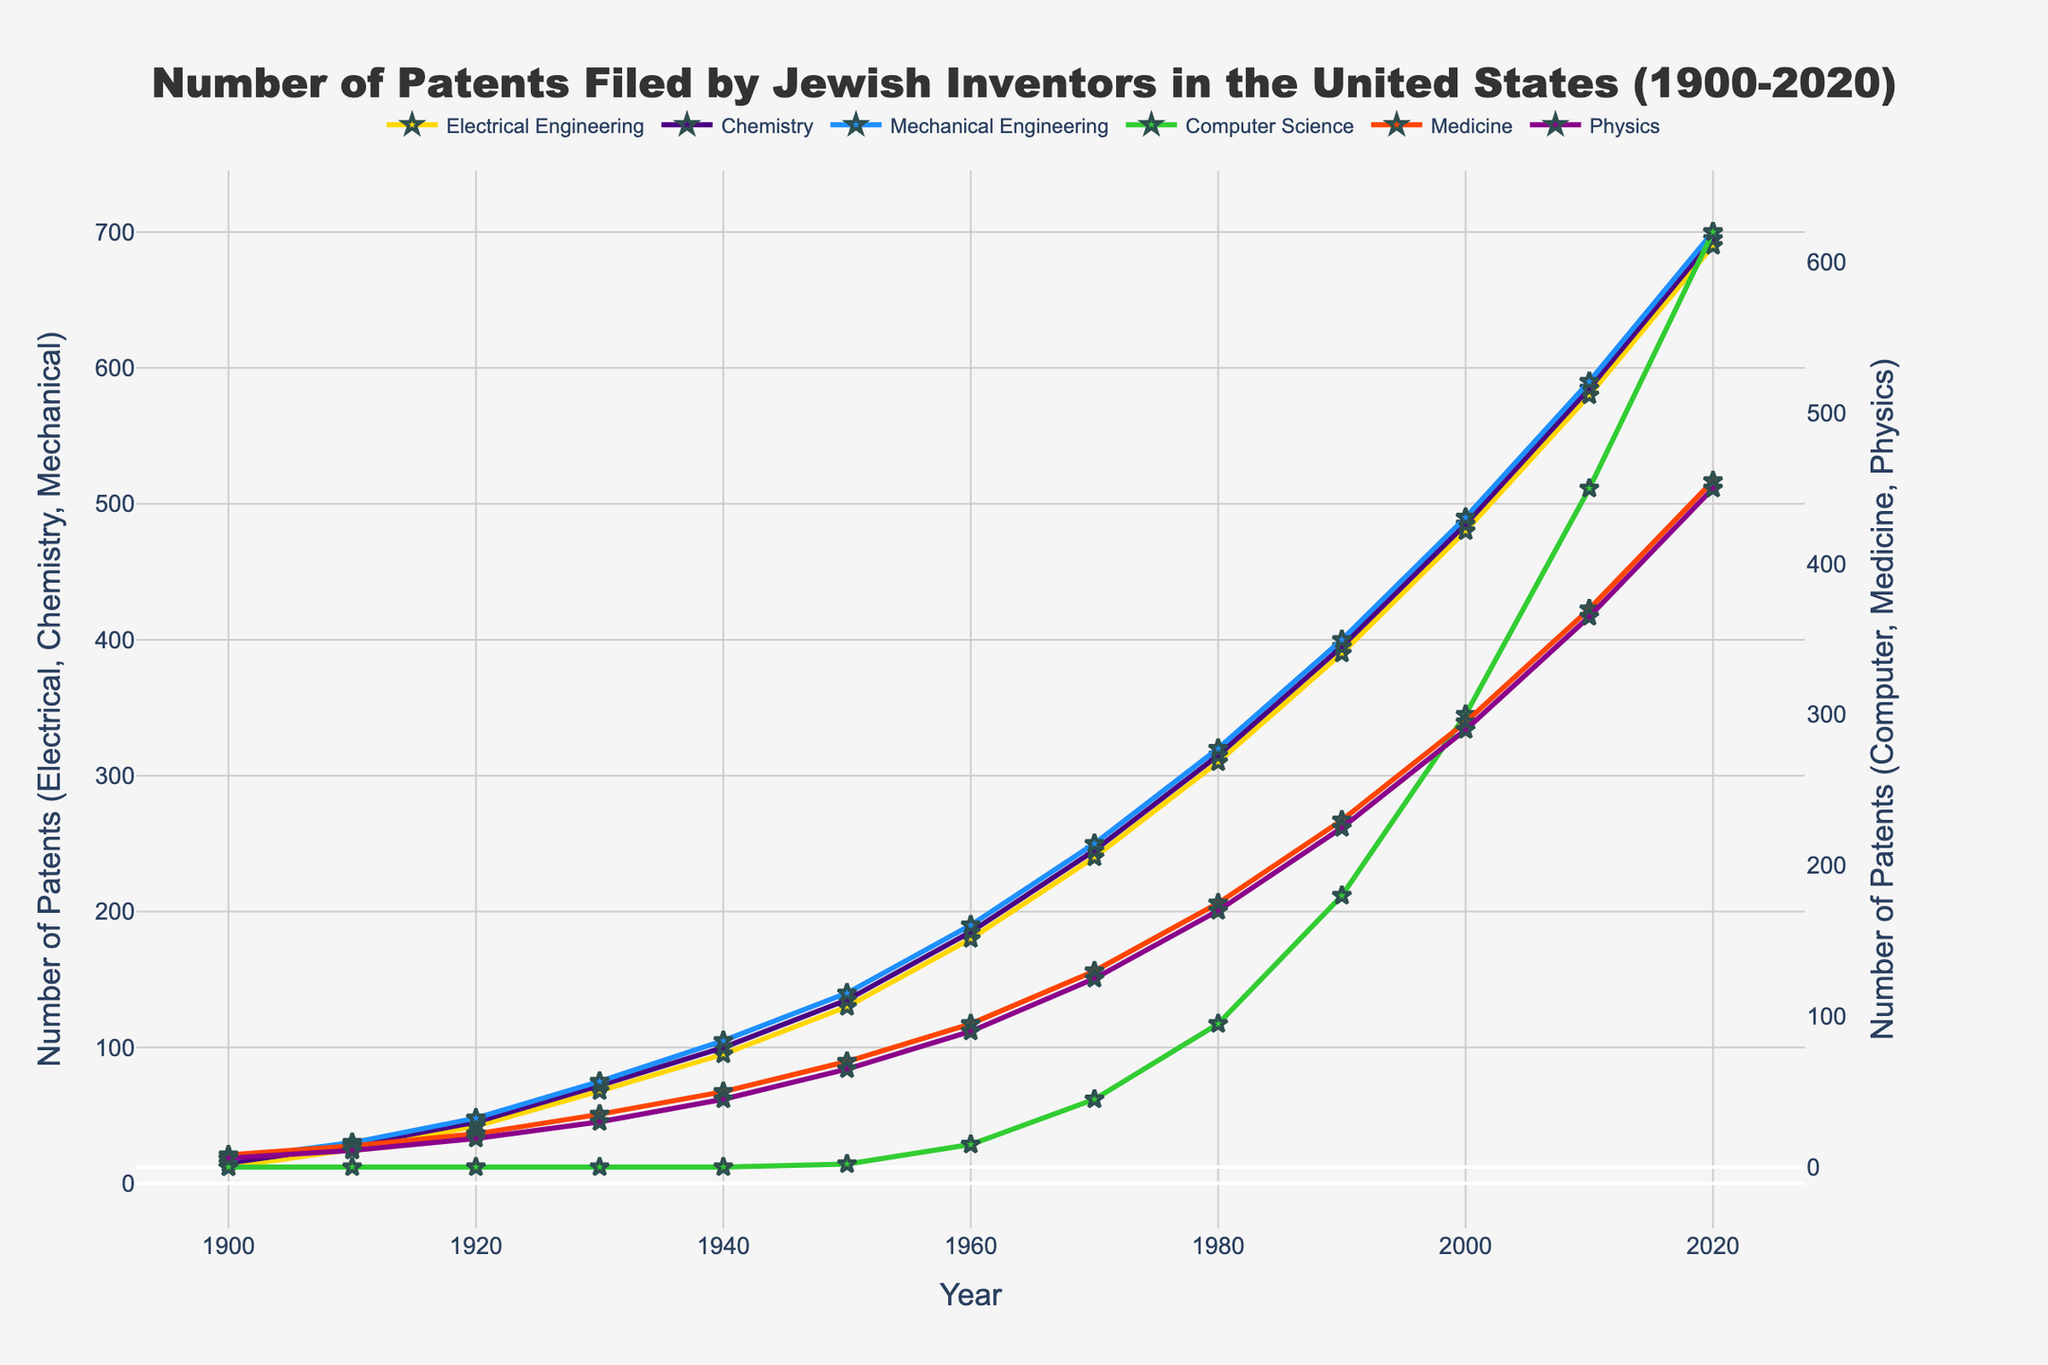what is the trend in the number of patents filed in Electrical Engineering from 1900 to 2020? From 1900 to 2020, the number of patents filed in Electrical Engineering shows an upward trend. In 1900, there were 12 patents, and by 2020, this number increased to 690. The increase is consistent over the decades.
Answer: Upward trend In which decade did Chemistry see the largest increase in patents filed? The number of patents filed in Chemistry increased the most between the 1950s (135 patents) and 1960s (185 patents). The increase is 185 - 135 = 50 patents.
Answer: 1950s to 1960s How does the number of patents filed in Computer Science in 2000 compare to 2010? In 2000, 300 patents were filed, and by 2010, it increased to 450 patents. The difference is 450 - 300 = 150.
Answer: 150 more in 2010 Which field had the highest number of patents filed in 2020? In 2020, Mechanical Engineering had the highest number of patents filed at 700.
Answer: Mechanical Engineering What is the total number of patents filed over all fields in 2020? Sum the patents for all fields in 2020: 690 (Electrical Engineering) + 695 (Chemistry) + 700 (Mechanical Engineering) + 620 (Computer Science) + 455 (Medicine) + 450 (Physics) = 3610 patents.
Answer: 3610 patents What is the average number of patents filed in Medicine every decade from 1900 to 2020? Calculate the average number of patents for each decade and then find the average: (8 + 14 + 22 + 35 + 50 + 70 + 95 + 130 + 175 + 230 + 295 + 370 + 455) / 13 = 197. Pharmacy has an average of 197 patents per decade.
Answer: 197 patents Which fields show a consistent increase over all the decades from 1900 to 2020? Examining the data, Electrical Engineering, Chemistry, Mechanical Engineering, and Medicine show a consistent increase in the number of patents filed every decade.
Answer: Electrical Engineering, Chemistry, Mechanical Engineering, Medicine How many more patents were filed in Physics in 2020 compared to 1900? In 1900, 6 patents were filed in Physics, and in 2020, it increased to 450 patents. The difference is 450 - 6 = 444.
Answer: 444 more patents By how much did the number of patents in Mechanical Engineering surpass those in Chemistry in 2020? In 2020, Mechanical Engineering had 700 patents, while Chemistry had 695 patents. The difference is 700 - 695 = 5.
Answer: 5 more patents 